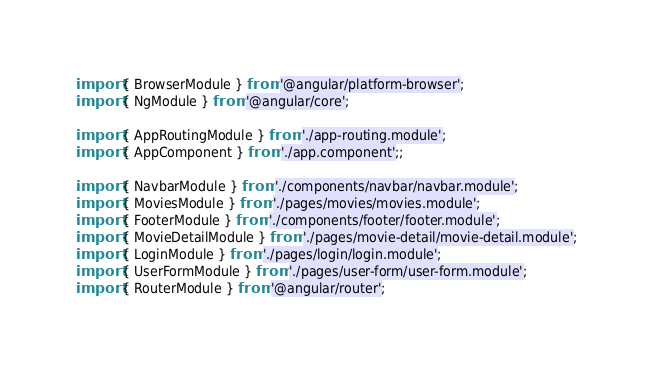<code> <loc_0><loc_0><loc_500><loc_500><_TypeScript_>import { BrowserModule } from '@angular/platform-browser';
import { NgModule } from '@angular/core';

import { AppRoutingModule } from './app-routing.module';
import { AppComponent } from './app.component';;

import { NavbarModule } from './components/navbar/navbar.module';
import { MoviesModule } from './pages/movies/movies.module';
import { FooterModule } from './components/footer/footer.module';
import { MovieDetailModule } from './pages/movie-detail/movie-detail.module';
import { LoginModule } from './pages/login/login.module';
import { UserFormModule } from './pages/user-form/user-form.module';
import { RouterModule } from '@angular/router';</code> 